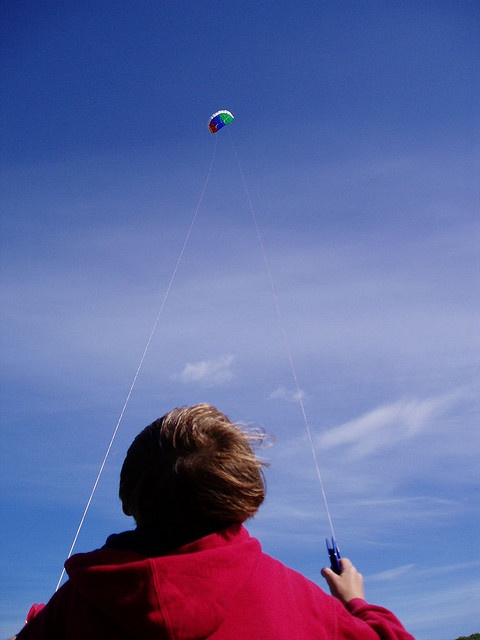Describe the objects in this image and their specific colors. I can see people in navy, black, brown, and maroon tones and kite in navy, darkblue, green, blue, and maroon tones in this image. 